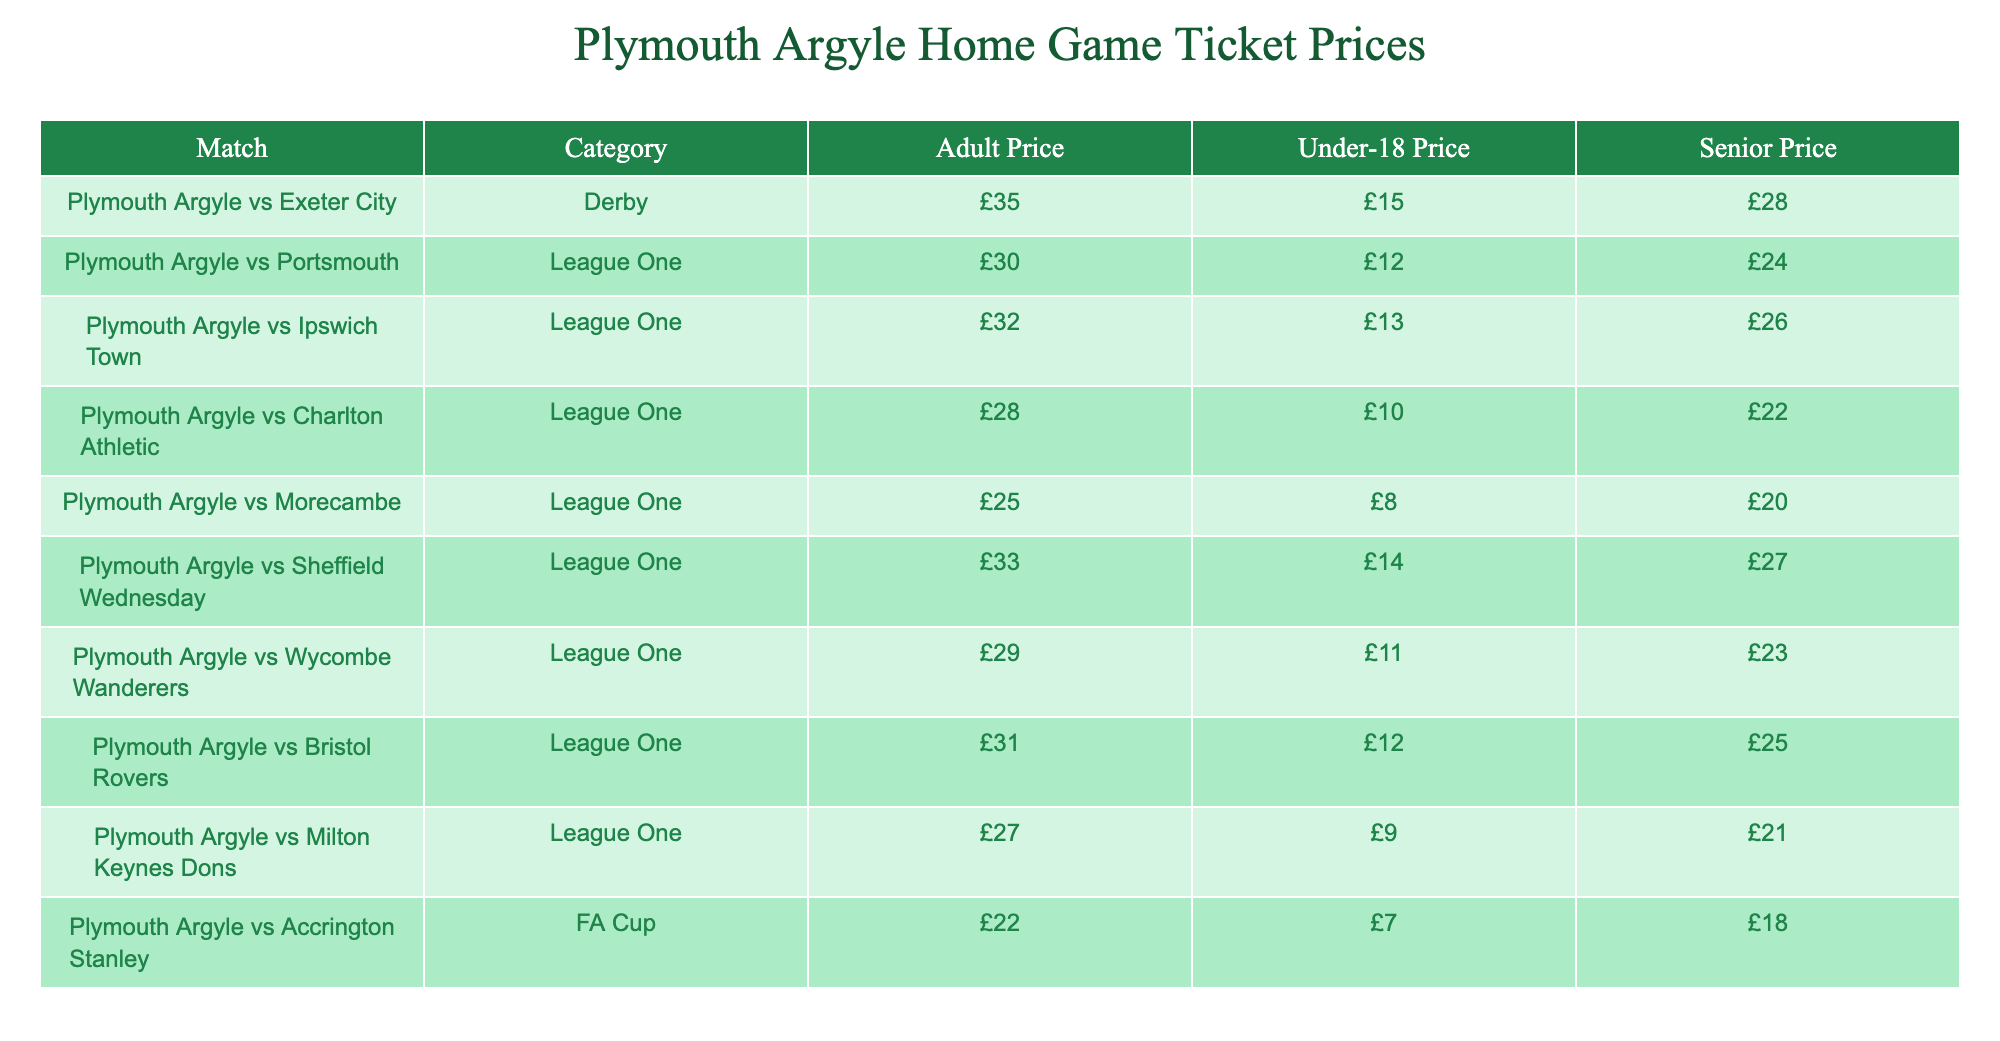What is the adult price for the match against Exeter City? The table lists the match against Exeter City and specifies that the adult ticket price is £35.
Answer: £35 What is the price difference between adult tickets for the match against Portsmouth and Ipswich Town? The adult ticket price for Portsmouth is £30, while for Ipswich Town, it is £32. The price difference is calculated as 32 - 30 = 2.
Answer: £2 Are under-18 tickets cheaper for the match against Charlton Athletic compared to the match against Morecambe? The under-18 price for Charlton Athletic is £10 and for Morecambe is £8. Since £10 is greater than £8, under-18 tickets are not cheaper for Charlton Athletic.
Answer: No What is the senior ticket price for the match against Sheffield Wednesday? The table shows that the senior ticket price for Sheffield Wednesday is £27.
Answer: £27 What is the average adult price for all the matches listed in the table? To calculate the average, first sum the adult prices: (35 + 30 + 32 + 28 + 25 + 33 + 29 + 31 + 27 + 22) =  27. Since there are 10 matches, divide the total by 10:  27/10 = 27.
Answer: £27 Is the adult ticket price for the match against Bristol Rovers higher than that for the match against Wycombe Wanderers? The adult ticket price for Bristol Rovers is £31 and for Wycombe Wanderers is £29. Since £31 is greater than £29, the adult ticket price for Bristol Rovers is higher.
Answer: Yes What is the cheapest under-18 ticket price available for these matches? Looking through the under-18 prices: £15, £12, £13, £10, £8, £14, £11, £12, £9, £7. The lowest among these is £7, which is for the match against Accrington Stanley.
Answer: £7 What is the total cost for a family of two adults and one under-18 child to attend the match against Ipswich Town? The adult price for Ipswich Town is £32, so for two adults, it would be 2 x £32 = £64. The under-18 price is £13. Therefore, the total cost is £64 + £13 = £77.
Answer: £77 Which match has the highest ticket price for adults? The ticket prices for adults are as follows: £35 for Exeter City, £30 for Portsmouth, £32 for Ipswich Town, £28 for Charlton Athletic, £25 for Morecambe, £33 for Sheffield Wednesday, £29 for Wycombe Wanderers, £31 for Bristol Rovers, £27 for Milton Keynes Dons, and £22 for Accrington Stanley. The highest price is £35 for the match against Exeter City.
Answer: £35 